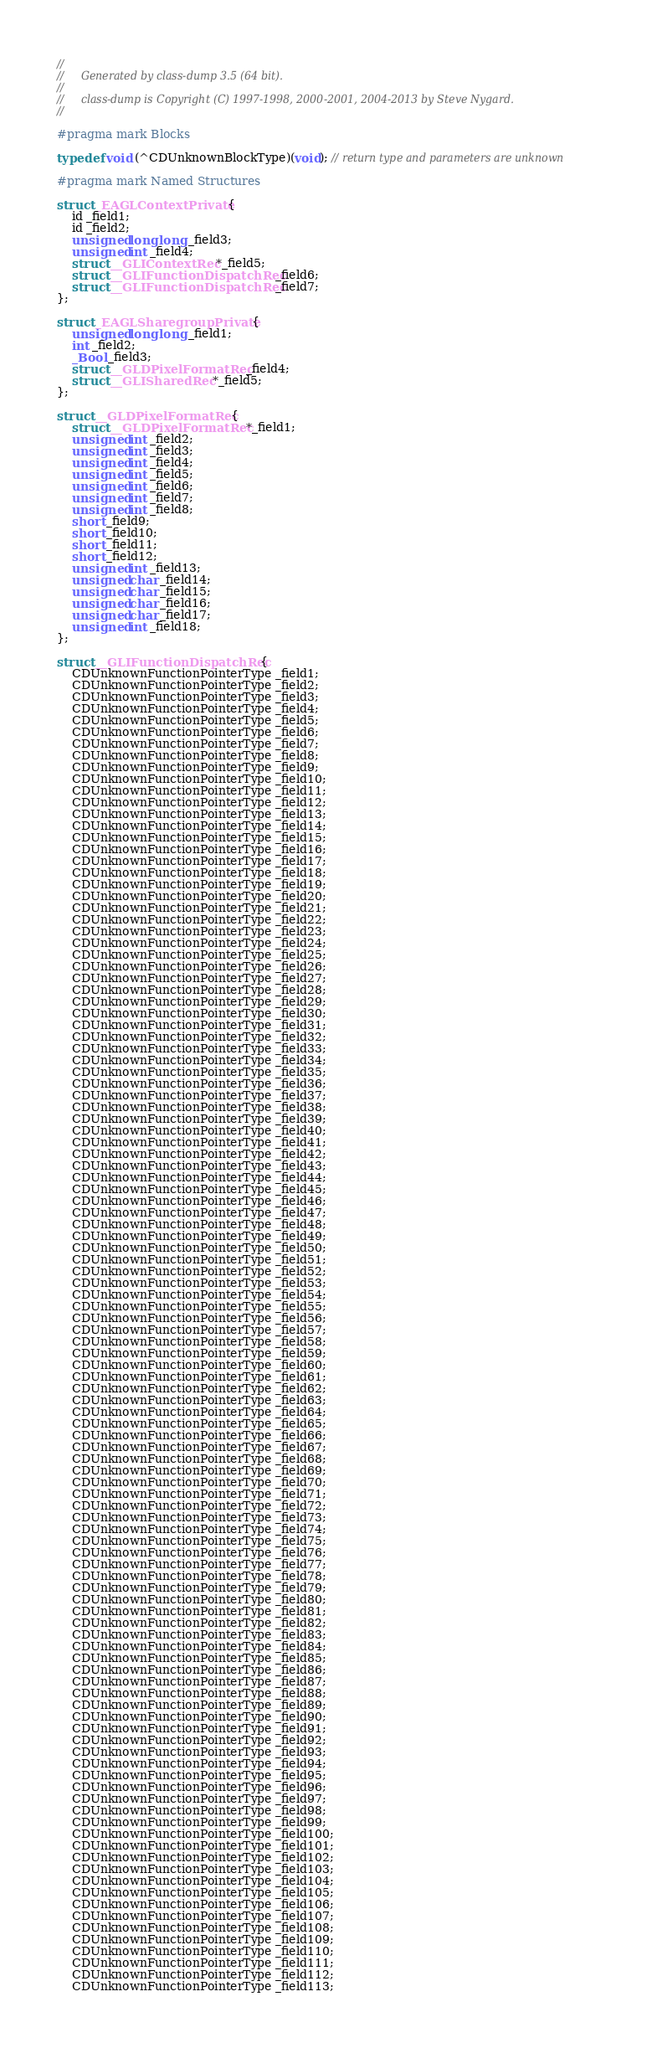Convert code to text. <code><loc_0><loc_0><loc_500><loc_500><_C_>//
//     Generated by class-dump 3.5 (64 bit).
//
//     class-dump is Copyright (C) 1997-1998, 2000-2001, 2004-2013 by Steve Nygard.
//

#pragma mark Blocks

typedef void (^CDUnknownBlockType)(void); // return type and parameters are unknown

#pragma mark Named Structures

struct _EAGLContextPrivate {
    id _field1;
    id _field2;
    unsigned long long _field3;
    unsigned int _field4;
    struct __GLIContextRec *_field5;
    struct __GLIFunctionDispatchRec _field6;
    struct __GLIFunctionDispatchRec _field7;
};

struct _EAGLSharegroupPrivate {
    unsigned long long _field1;
    int _field2;
    _Bool _field3;
    struct __GLDPixelFormatRec _field4;
    struct __GLISharedRec *_field5;
};

struct __GLDPixelFormatRec {
    struct __GLDPixelFormatRec *_field1;
    unsigned int _field2;
    unsigned int _field3;
    unsigned int _field4;
    unsigned int _field5;
    unsigned int _field6;
    unsigned int _field7;
    unsigned int _field8;
    short _field9;
    short _field10;
    short _field11;
    short _field12;
    unsigned int _field13;
    unsigned char _field14;
    unsigned char _field15;
    unsigned char _field16;
    unsigned char _field17;
    unsigned int _field18;
};

struct __GLIFunctionDispatchRec {
    CDUnknownFunctionPointerType _field1;
    CDUnknownFunctionPointerType _field2;
    CDUnknownFunctionPointerType _field3;
    CDUnknownFunctionPointerType _field4;
    CDUnknownFunctionPointerType _field5;
    CDUnknownFunctionPointerType _field6;
    CDUnknownFunctionPointerType _field7;
    CDUnknownFunctionPointerType _field8;
    CDUnknownFunctionPointerType _field9;
    CDUnknownFunctionPointerType _field10;
    CDUnknownFunctionPointerType _field11;
    CDUnknownFunctionPointerType _field12;
    CDUnknownFunctionPointerType _field13;
    CDUnknownFunctionPointerType _field14;
    CDUnknownFunctionPointerType _field15;
    CDUnknownFunctionPointerType _field16;
    CDUnknownFunctionPointerType _field17;
    CDUnknownFunctionPointerType _field18;
    CDUnknownFunctionPointerType _field19;
    CDUnknownFunctionPointerType _field20;
    CDUnknownFunctionPointerType _field21;
    CDUnknownFunctionPointerType _field22;
    CDUnknownFunctionPointerType _field23;
    CDUnknownFunctionPointerType _field24;
    CDUnknownFunctionPointerType _field25;
    CDUnknownFunctionPointerType _field26;
    CDUnknownFunctionPointerType _field27;
    CDUnknownFunctionPointerType _field28;
    CDUnknownFunctionPointerType _field29;
    CDUnknownFunctionPointerType _field30;
    CDUnknownFunctionPointerType _field31;
    CDUnknownFunctionPointerType _field32;
    CDUnknownFunctionPointerType _field33;
    CDUnknownFunctionPointerType _field34;
    CDUnknownFunctionPointerType _field35;
    CDUnknownFunctionPointerType _field36;
    CDUnknownFunctionPointerType _field37;
    CDUnknownFunctionPointerType _field38;
    CDUnknownFunctionPointerType _field39;
    CDUnknownFunctionPointerType _field40;
    CDUnknownFunctionPointerType _field41;
    CDUnknownFunctionPointerType _field42;
    CDUnknownFunctionPointerType _field43;
    CDUnknownFunctionPointerType _field44;
    CDUnknownFunctionPointerType _field45;
    CDUnknownFunctionPointerType _field46;
    CDUnknownFunctionPointerType _field47;
    CDUnknownFunctionPointerType _field48;
    CDUnknownFunctionPointerType _field49;
    CDUnknownFunctionPointerType _field50;
    CDUnknownFunctionPointerType _field51;
    CDUnknownFunctionPointerType _field52;
    CDUnknownFunctionPointerType _field53;
    CDUnknownFunctionPointerType _field54;
    CDUnknownFunctionPointerType _field55;
    CDUnknownFunctionPointerType _field56;
    CDUnknownFunctionPointerType _field57;
    CDUnknownFunctionPointerType _field58;
    CDUnknownFunctionPointerType _field59;
    CDUnknownFunctionPointerType _field60;
    CDUnknownFunctionPointerType _field61;
    CDUnknownFunctionPointerType _field62;
    CDUnknownFunctionPointerType _field63;
    CDUnknownFunctionPointerType _field64;
    CDUnknownFunctionPointerType _field65;
    CDUnknownFunctionPointerType _field66;
    CDUnknownFunctionPointerType _field67;
    CDUnknownFunctionPointerType _field68;
    CDUnknownFunctionPointerType _field69;
    CDUnknownFunctionPointerType _field70;
    CDUnknownFunctionPointerType _field71;
    CDUnknownFunctionPointerType _field72;
    CDUnknownFunctionPointerType _field73;
    CDUnknownFunctionPointerType _field74;
    CDUnknownFunctionPointerType _field75;
    CDUnknownFunctionPointerType _field76;
    CDUnknownFunctionPointerType _field77;
    CDUnknownFunctionPointerType _field78;
    CDUnknownFunctionPointerType _field79;
    CDUnknownFunctionPointerType _field80;
    CDUnknownFunctionPointerType _field81;
    CDUnknownFunctionPointerType _field82;
    CDUnknownFunctionPointerType _field83;
    CDUnknownFunctionPointerType _field84;
    CDUnknownFunctionPointerType _field85;
    CDUnknownFunctionPointerType _field86;
    CDUnknownFunctionPointerType _field87;
    CDUnknownFunctionPointerType _field88;
    CDUnknownFunctionPointerType _field89;
    CDUnknownFunctionPointerType _field90;
    CDUnknownFunctionPointerType _field91;
    CDUnknownFunctionPointerType _field92;
    CDUnknownFunctionPointerType _field93;
    CDUnknownFunctionPointerType _field94;
    CDUnknownFunctionPointerType _field95;
    CDUnknownFunctionPointerType _field96;
    CDUnknownFunctionPointerType _field97;
    CDUnknownFunctionPointerType _field98;
    CDUnknownFunctionPointerType _field99;
    CDUnknownFunctionPointerType _field100;
    CDUnknownFunctionPointerType _field101;
    CDUnknownFunctionPointerType _field102;
    CDUnknownFunctionPointerType _field103;
    CDUnknownFunctionPointerType _field104;
    CDUnknownFunctionPointerType _field105;
    CDUnknownFunctionPointerType _field106;
    CDUnknownFunctionPointerType _field107;
    CDUnknownFunctionPointerType _field108;
    CDUnknownFunctionPointerType _field109;
    CDUnknownFunctionPointerType _field110;
    CDUnknownFunctionPointerType _field111;
    CDUnknownFunctionPointerType _field112;
    CDUnknownFunctionPointerType _field113;</code> 